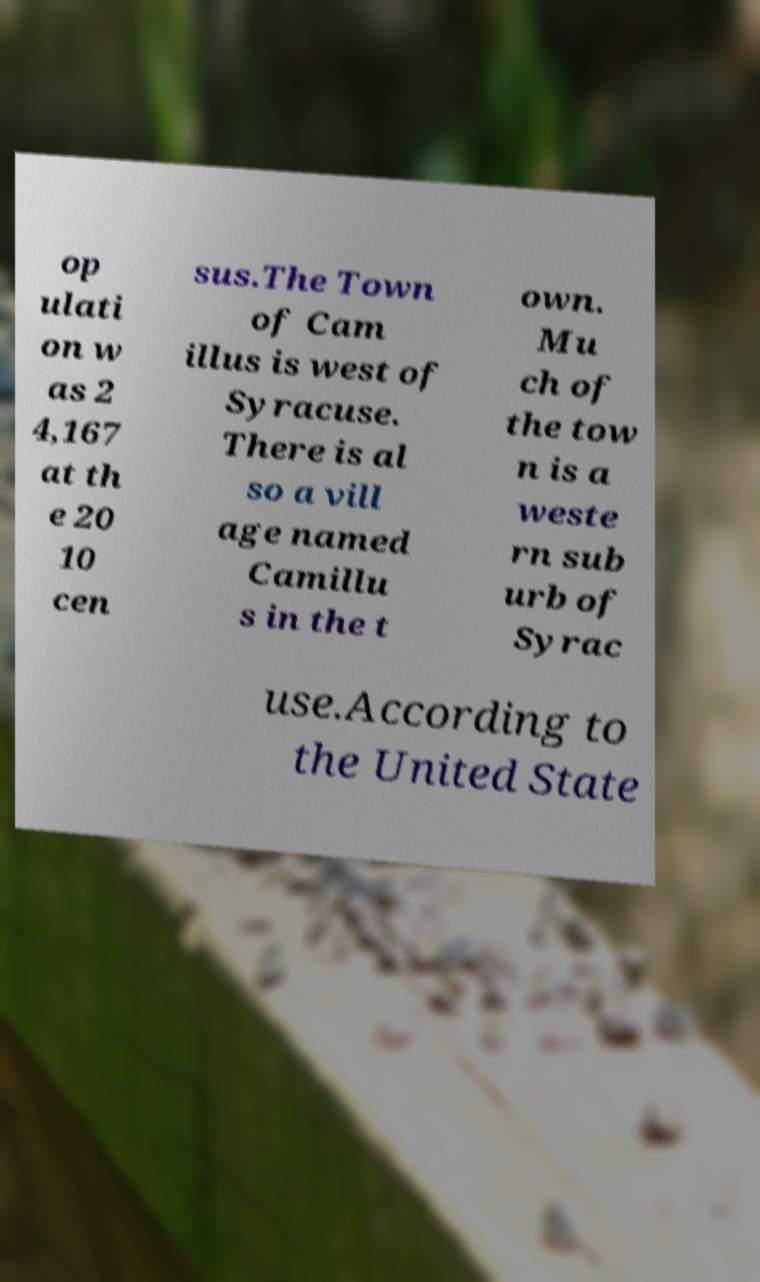Could you assist in decoding the text presented in this image and type it out clearly? op ulati on w as 2 4,167 at th e 20 10 cen sus.The Town of Cam illus is west of Syracuse. There is al so a vill age named Camillu s in the t own. Mu ch of the tow n is a weste rn sub urb of Syrac use.According to the United State 